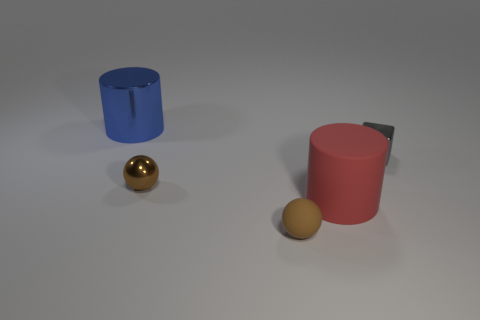Subtract 1 cubes. How many cubes are left? 0 Subtract all blue spheres. Subtract all purple cubes. How many spheres are left? 2 Subtract all yellow spheres. How many blue cubes are left? 0 Subtract all large cyan cubes. Subtract all small gray metallic objects. How many objects are left? 4 Add 4 rubber balls. How many rubber balls are left? 5 Add 5 small green metallic cylinders. How many small green metallic cylinders exist? 5 Add 5 red things. How many objects exist? 10 Subtract 1 red cylinders. How many objects are left? 4 Subtract all cylinders. How many objects are left? 3 